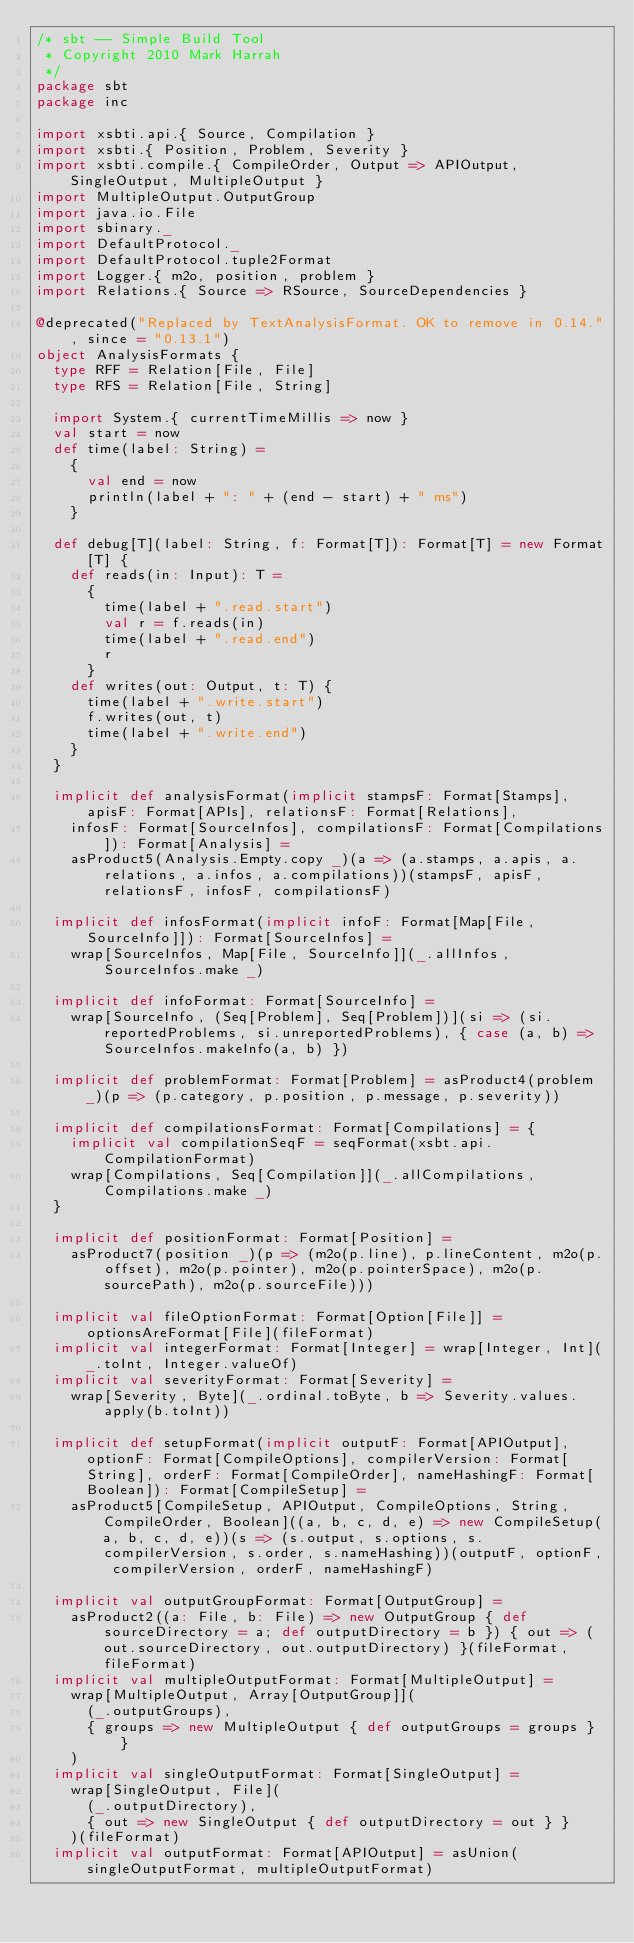<code> <loc_0><loc_0><loc_500><loc_500><_Scala_>/* sbt -- Simple Build Tool
 * Copyright 2010 Mark Harrah
 */
package sbt
package inc

import xsbti.api.{ Source, Compilation }
import xsbti.{ Position, Problem, Severity }
import xsbti.compile.{ CompileOrder, Output => APIOutput, SingleOutput, MultipleOutput }
import MultipleOutput.OutputGroup
import java.io.File
import sbinary._
import DefaultProtocol._
import DefaultProtocol.tuple2Format
import Logger.{ m2o, position, problem }
import Relations.{ Source => RSource, SourceDependencies }

@deprecated("Replaced by TextAnalysisFormat. OK to remove in 0.14.", since = "0.13.1")
object AnalysisFormats {
  type RFF = Relation[File, File]
  type RFS = Relation[File, String]

  import System.{ currentTimeMillis => now }
  val start = now
  def time(label: String) =
    {
      val end = now
      println(label + ": " + (end - start) + " ms")
    }

  def debug[T](label: String, f: Format[T]): Format[T] = new Format[T] {
    def reads(in: Input): T =
      {
        time(label + ".read.start")
        val r = f.reads(in)
        time(label + ".read.end")
        r
      }
    def writes(out: Output, t: T) {
      time(label + ".write.start")
      f.writes(out, t)
      time(label + ".write.end")
    }
  }

  implicit def analysisFormat(implicit stampsF: Format[Stamps], apisF: Format[APIs], relationsF: Format[Relations],
    infosF: Format[SourceInfos], compilationsF: Format[Compilations]): Format[Analysis] =
    asProduct5(Analysis.Empty.copy _)(a => (a.stamps, a.apis, a.relations, a.infos, a.compilations))(stampsF, apisF, relationsF, infosF, compilationsF)

  implicit def infosFormat(implicit infoF: Format[Map[File, SourceInfo]]): Format[SourceInfos] =
    wrap[SourceInfos, Map[File, SourceInfo]](_.allInfos, SourceInfos.make _)

  implicit def infoFormat: Format[SourceInfo] =
    wrap[SourceInfo, (Seq[Problem], Seq[Problem])](si => (si.reportedProblems, si.unreportedProblems), { case (a, b) => SourceInfos.makeInfo(a, b) })

  implicit def problemFormat: Format[Problem] = asProduct4(problem _)(p => (p.category, p.position, p.message, p.severity))

  implicit def compilationsFormat: Format[Compilations] = {
    implicit val compilationSeqF = seqFormat(xsbt.api.CompilationFormat)
    wrap[Compilations, Seq[Compilation]](_.allCompilations, Compilations.make _)
  }

  implicit def positionFormat: Format[Position] =
    asProduct7(position _)(p => (m2o(p.line), p.lineContent, m2o(p.offset), m2o(p.pointer), m2o(p.pointerSpace), m2o(p.sourcePath), m2o(p.sourceFile)))

  implicit val fileOptionFormat: Format[Option[File]] = optionsAreFormat[File](fileFormat)
  implicit val integerFormat: Format[Integer] = wrap[Integer, Int](_.toInt, Integer.valueOf)
  implicit val severityFormat: Format[Severity] =
    wrap[Severity, Byte](_.ordinal.toByte, b => Severity.values.apply(b.toInt))

  implicit def setupFormat(implicit outputF: Format[APIOutput], optionF: Format[CompileOptions], compilerVersion: Format[String], orderF: Format[CompileOrder], nameHashingF: Format[Boolean]): Format[CompileSetup] =
    asProduct5[CompileSetup, APIOutput, CompileOptions, String, CompileOrder, Boolean]((a, b, c, d, e) => new CompileSetup(a, b, c, d, e))(s => (s.output, s.options, s.compilerVersion, s.order, s.nameHashing))(outputF, optionF, compilerVersion, orderF, nameHashingF)

  implicit val outputGroupFormat: Format[OutputGroup] =
    asProduct2((a: File, b: File) => new OutputGroup { def sourceDirectory = a; def outputDirectory = b }) { out => (out.sourceDirectory, out.outputDirectory) }(fileFormat, fileFormat)
  implicit val multipleOutputFormat: Format[MultipleOutput] =
    wrap[MultipleOutput, Array[OutputGroup]](
      (_.outputGroups),
      { groups => new MultipleOutput { def outputGroups = groups } }
    )
  implicit val singleOutputFormat: Format[SingleOutput] =
    wrap[SingleOutput, File](
      (_.outputDirectory),
      { out => new SingleOutput { def outputDirectory = out } }
    )(fileFormat)
  implicit val outputFormat: Format[APIOutput] = asUnion(singleOutputFormat, multipleOutputFormat)
</code> 